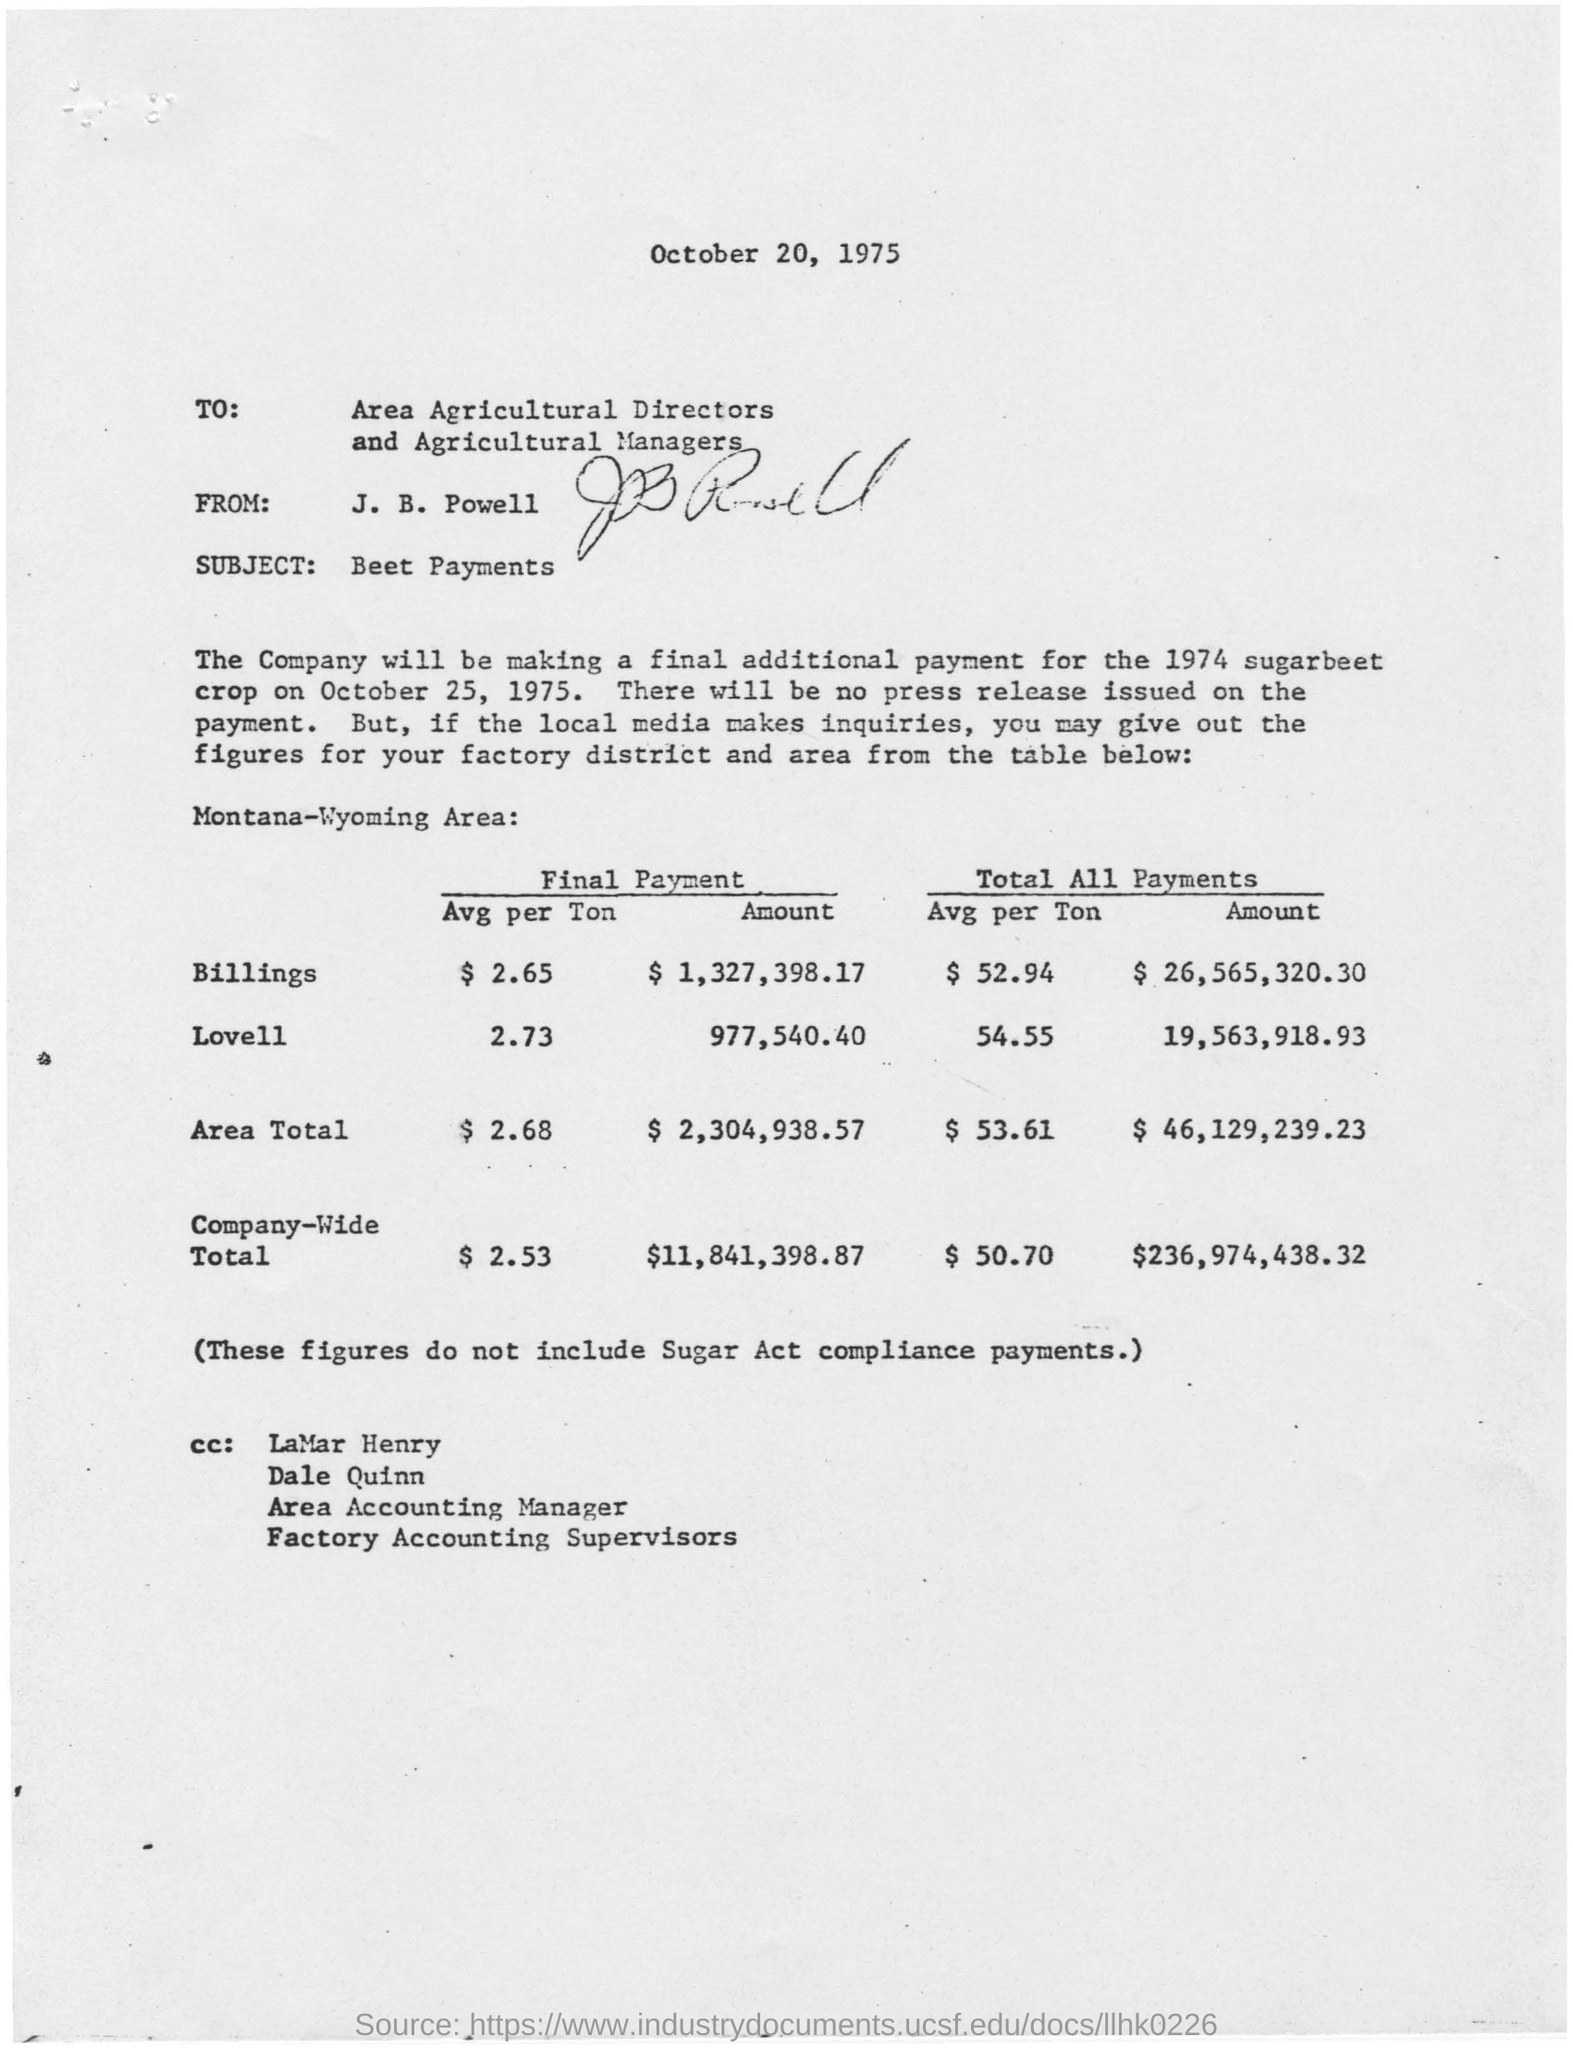Mention a couple of crucial points in this snapshot. The subject of this letter is Beet Payments. The final payment amount for Area Total is $2,304,938.57. The final payment amount for the company-wide total is $11,841,398.87. The letter is from J. B. Powell. The issued date of the letter is October 20, 1975. 